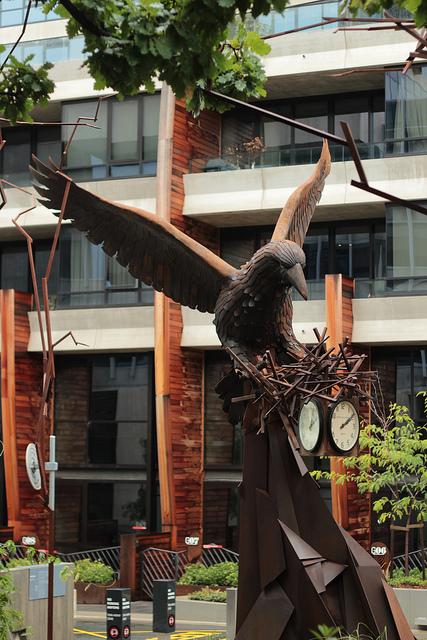What time is shown?
Quick response, please. 2:10. Would this sculpture be described as rustic or modern?
Quick response, please. Rustic. Is the bird part of this sculpture?
Answer briefly. Yes. 